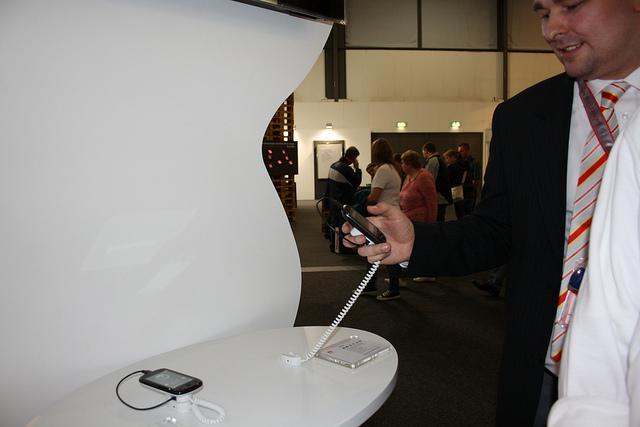Is this item attached to the desk?
Give a very brief answer. Yes. Are both phones likely his?
Keep it brief. No. What kind of expression is on the man's face?
Give a very brief answer. Smile. What color is the tie?
Short answer required. Orange and white. 